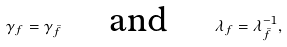Convert formula to latex. <formula><loc_0><loc_0><loc_500><loc_500>\gamma _ { f } = \gamma _ { \bar { f } } \quad \text { and } \quad \lambda _ { f } = \lambda _ { \bar { f } } ^ { - 1 } ,</formula> 